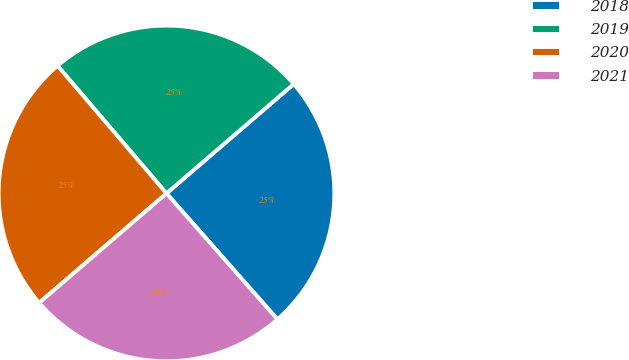<chart> <loc_0><loc_0><loc_500><loc_500><pie_chart><fcel>2018<fcel>2019<fcel>2020<fcel>2021<nl><fcel>24.81%<fcel>24.94%<fcel>25.06%<fcel>25.19%<nl></chart> 